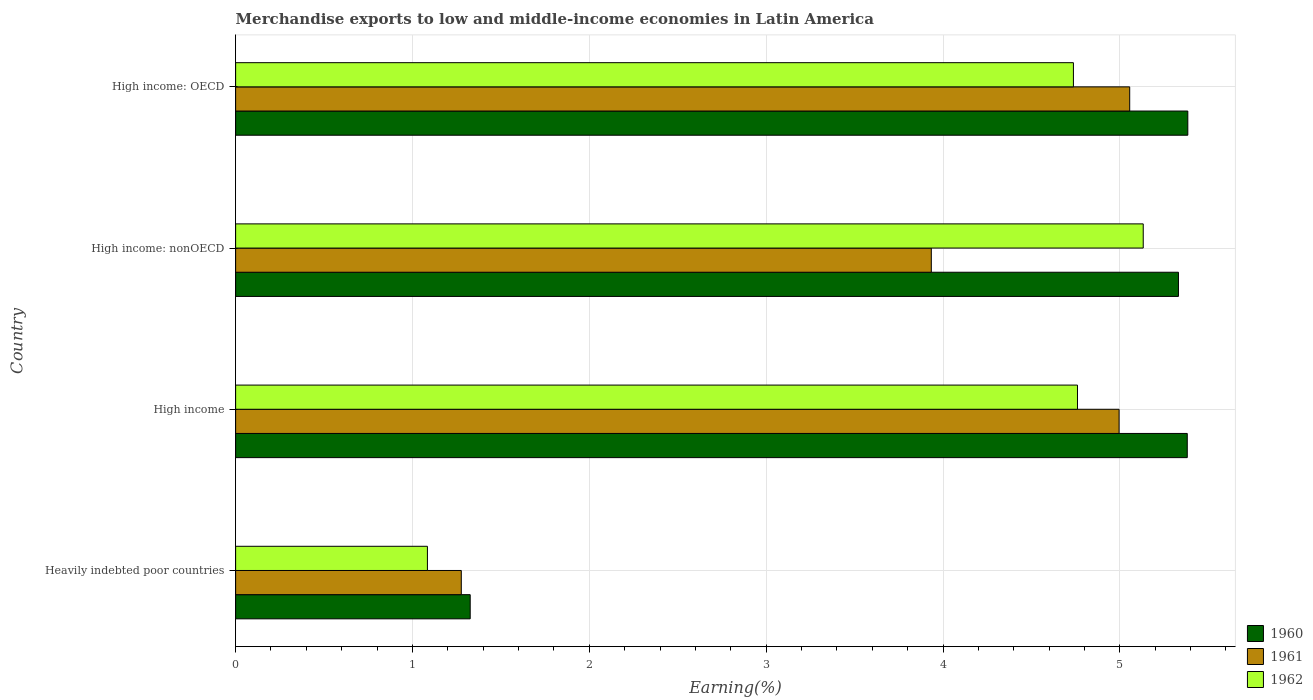How many bars are there on the 1st tick from the top?
Make the answer very short. 3. What is the label of the 2nd group of bars from the top?
Your response must be concise. High income: nonOECD. What is the percentage of amount earned from merchandise exports in 1961 in High income: OECD?
Make the answer very short. 5.06. Across all countries, what is the maximum percentage of amount earned from merchandise exports in 1960?
Keep it short and to the point. 5.38. Across all countries, what is the minimum percentage of amount earned from merchandise exports in 1960?
Offer a very short reply. 1.33. In which country was the percentage of amount earned from merchandise exports in 1962 maximum?
Keep it short and to the point. High income: nonOECD. In which country was the percentage of amount earned from merchandise exports in 1962 minimum?
Offer a very short reply. Heavily indebted poor countries. What is the total percentage of amount earned from merchandise exports in 1961 in the graph?
Keep it short and to the point. 15.26. What is the difference between the percentage of amount earned from merchandise exports in 1961 in Heavily indebted poor countries and that in High income: nonOECD?
Give a very brief answer. -2.66. What is the difference between the percentage of amount earned from merchandise exports in 1962 in High income: OECD and the percentage of amount earned from merchandise exports in 1961 in High income?
Give a very brief answer. -0.26. What is the average percentage of amount earned from merchandise exports in 1961 per country?
Provide a short and direct response. 3.82. What is the difference between the percentage of amount earned from merchandise exports in 1960 and percentage of amount earned from merchandise exports in 1961 in High income?
Keep it short and to the point. 0.39. In how many countries, is the percentage of amount earned from merchandise exports in 1961 greater than 2.2 %?
Your answer should be compact. 3. What is the ratio of the percentage of amount earned from merchandise exports in 1962 in High income to that in High income: OECD?
Keep it short and to the point. 1. Is the difference between the percentage of amount earned from merchandise exports in 1960 in Heavily indebted poor countries and High income: nonOECD greater than the difference between the percentage of amount earned from merchandise exports in 1961 in Heavily indebted poor countries and High income: nonOECD?
Your response must be concise. No. What is the difference between the highest and the second highest percentage of amount earned from merchandise exports in 1960?
Your answer should be very brief. 0. What is the difference between the highest and the lowest percentage of amount earned from merchandise exports in 1961?
Offer a terse response. 3.78. In how many countries, is the percentage of amount earned from merchandise exports in 1960 greater than the average percentage of amount earned from merchandise exports in 1960 taken over all countries?
Provide a short and direct response. 3. What does the 2nd bar from the bottom in High income represents?
Your response must be concise. 1961. Is it the case that in every country, the sum of the percentage of amount earned from merchandise exports in 1962 and percentage of amount earned from merchandise exports in 1961 is greater than the percentage of amount earned from merchandise exports in 1960?
Keep it short and to the point. Yes. How many countries are there in the graph?
Offer a very short reply. 4. Does the graph contain any zero values?
Offer a terse response. No. Does the graph contain grids?
Give a very brief answer. Yes. How are the legend labels stacked?
Offer a terse response. Vertical. What is the title of the graph?
Make the answer very short. Merchandise exports to low and middle-income economies in Latin America. What is the label or title of the X-axis?
Offer a very short reply. Earning(%). What is the Earning(%) in 1960 in Heavily indebted poor countries?
Offer a very short reply. 1.33. What is the Earning(%) in 1961 in Heavily indebted poor countries?
Your answer should be compact. 1.28. What is the Earning(%) of 1962 in Heavily indebted poor countries?
Provide a short and direct response. 1.08. What is the Earning(%) of 1960 in High income?
Make the answer very short. 5.38. What is the Earning(%) of 1961 in High income?
Provide a succinct answer. 5. What is the Earning(%) of 1962 in High income?
Your response must be concise. 4.76. What is the Earning(%) of 1960 in High income: nonOECD?
Keep it short and to the point. 5.33. What is the Earning(%) of 1961 in High income: nonOECD?
Make the answer very short. 3.93. What is the Earning(%) in 1962 in High income: nonOECD?
Your response must be concise. 5.13. What is the Earning(%) of 1960 in High income: OECD?
Give a very brief answer. 5.38. What is the Earning(%) of 1961 in High income: OECD?
Give a very brief answer. 5.06. What is the Earning(%) of 1962 in High income: OECD?
Give a very brief answer. 4.74. Across all countries, what is the maximum Earning(%) in 1960?
Offer a terse response. 5.38. Across all countries, what is the maximum Earning(%) of 1961?
Make the answer very short. 5.06. Across all countries, what is the maximum Earning(%) in 1962?
Provide a succinct answer. 5.13. Across all countries, what is the minimum Earning(%) in 1960?
Provide a succinct answer. 1.33. Across all countries, what is the minimum Earning(%) in 1961?
Give a very brief answer. 1.28. Across all countries, what is the minimum Earning(%) of 1962?
Ensure brevity in your answer.  1.08. What is the total Earning(%) of 1960 in the graph?
Your response must be concise. 17.42. What is the total Earning(%) in 1961 in the graph?
Provide a short and direct response. 15.26. What is the total Earning(%) in 1962 in the graph?
Make the answer very short. 15.71. What is the difference between the Earning(%) in 1960 in Heavily indebted poor countries and that in High income?
Make the answer very short. -4.05. What is the difference between the Earning(%) in 1961 in Heavily indebted poor countries and that in High income?
Offer a very short reply. -3.72. What is the difference between the Earning(%) in 1962 in Heavily indebted poor countries and that in High income?
Your answer should be compact. -3.68. What is the difference between the Earning(%) of 1960 in Heavily indebted poor countries and that in High income: nonOECD?
Make the answer very short. -4. What is the difference between the Earning(%) of 1961 in Heavily indebted poor countries and that in High income: nonOECD?
Ensure brevity in your answer.  -2.66. What is the difference between the Earning(%) in 1962 in Heavily indebted poor countries and that in High income: nonOECD?
Provide a succinct answer. -4.05. What is the difference between the Earning(%) of 1960 in Heavily indebted poor countries and that in High income: OECD?
Your answer should be compact. -4.06. What is the difference between the Earning(%) of 1961 in Heavily indebted poor countries and that in High income: OECD?
Provide a succinct answer. -3.78. What is the difference between the Earning(%) of 1962 in Heavily indebted poor countries and that in High income: OECD?
Keep it short and to the point. -3.65. What is the difference between the Earning(%) of 1960 in High income and that in High income: nonOECD?
Your response must be concise. 0.05. What is the difference between the Earning(%) in 1961 in High income and that in High income: nonOECD?
Offer a very short reply. 1.06. What is the difference between the Earning(%) in 1962 in High income and that in High income: nonOECD?
Offer a very short reply. -0.37. What is the difference between the Earning(%) of 1960 in High income and that in High income: OECD?
Give a very brief answer. -0. What is the difference between the Earning(%) of 1961 in High income and that in High income: OECD?
Offer a terse response. -0.06. What is the difference between the Earning(%) of 1962 in High income and that in High income: OECD?
Provide a short and direct response. 0.02. What is the difference between the Earning(%) in 1960 in High income: nonOECD and that in High income: OECD?
Provide a short and direct response. -0.05. What is the difference between the Earning(%) of 1961 in High income: nonOECD and that in High income: OECD?
Make the answer very short. -1.12. What is the difference between the Earning(%) of 1962 in High income: nonOECD and that in High income: OECD?
Provide a short and direct response. 0.39. What is the difference between the Earning(%) in 1960 in Heavily indebted poor countries and the Earning(%) in 1961 in High income?
Ensure brevity in your answer.  -3.67. What is the difference between the Earning(%) of 1960 in Heavily indebted poor countries and the Earning(%) of 1962 in High income?
Give a very brief answer. -3.43. What is the difference between the Earning(%) of 1961 in Heavily indebted poor countries and the Earning(%) of 1962 in High income?
Provide a succinct answer. -3.48. What is the difference between the Earning(%) in 1960 in Heavily indebted poor countries and the Earning(%) in 1961 in High income: nonOECD?
Provide a short and direct response. -2.61. What is the difference between the Earning(%) in 1960 in Heavily indebted poor countries and the Earning(%) in 1962 in High income: nonOECD?
Provide a succinct answer. -3.81. What is the difference between the Earning(%) of 1961 in Heavily indebted poor countries and the Earning(%) of 1962 in High income: nonOECD?
Provide a succinct answer. -3.86. What is the difference between the Earning(%) in 1960 in Heavily indebted poor countries and the Earning(%) in 1961 in High income: OECD?
Your answer should be very brief. -3.73. What is the difference between the Earning(%) in 1960 in Heavily indebted poor countries and the Earning(%) in 1962 in High income: OECD?
Keep it short and to the point. -3.41. What is the difference between the Earning(%) in 1961 in Heavily indebted poor countries and the Earning(%) in 1962 in High income: OECD?
Provide a short and direct response. -3.46. What is the difference between the Earning(%) of 1960 in High income and the Earning(%) of 1961 in High income: nonOECD?
Make the answer very short. 1.45. What is the difference between the Earning(%) in 1960 in High income and the Earning(%) in 1962 in High income: nonOECD?
Make the answer very short. 0.25. What is the difference between the Earning(%) in 1961 in High income and the Earning(%) in 1962 in High income: nonOECD?
Keep it short and to the point. -0.14. What is the difference between the Earning(%) of 1960 in High income and the Earning(%) of 1961 in High income: OECD?
Offer a terse response. 0.33. What is the difference between the Earning(%) of 1960 in High income and the Earning(%) of 1962 in High income: OECD?
Your answer should be compact. 0.64. What is the difference between the Earning(%) of 1961 in High income and the Earning(%) of 1962 in High income: OECD?
Provide a succinct answer. 0.26. What is the difference between the Earning(%) in 1960 in High income: nonOECD and the Earning(%) in 1961 in High income: OECD?
Make the answer very short. 0.28. What is the difference between the Earning(%) of 1960 in High income: nonOECD and the Earning(%) of 1962 in High income: OECD?
Your answer should be compact. 0.59. What is the difference between the Earning(%) of 1961 in High income: nonOECD and the Earning(%) of 1962 in High income: OECD?
Offer a very short reply. -0.8. What is the average Earning(%) of 1960 per country?
Provide a short and direct response. 4.36. What is the average Earning(%) of 1961 per country?
Your answer should be very brief. 3.82. What is the average Earning(%) of 1962 per country?
Your answer should be very brief. 3.93. What is the difference between the Earning(%) of 1960 and Earning(%) of 1961 in Heavily indebted poor countries?
Offer a very short reply. 0.05. What is the difference between the Earning(%) in 1960 and Earning(%) in 1962 in Heavily indebted poor countries?
Give a very brief answer. 0.24. What is the difference between the Earning(%) in 1961 and Earning(%) in 1962 in Heavily indebted poor countries?
Your answer should be compact. 0.19. What is the difference between the Earning(%) of 1960 and Earning(%) of 1961 in High income?
Your answer should be very brief. 0.39. What is the difference between the Earning(%) in 1960 and Earning(%) in 1962 in High income?
Offer a terse response. 0.62. What is the difference between the Earning(%) of 1961 and Earning(%) of 1962 in High income?
Offer a terse response. 0.24. What is the difference between the Earning(%) of 1960 and Earning(%) of 1961 in High income: nonOECD?
Provide a short and direct response. 1.4. What is the difference between the Earning(%) of 1960 and Earning(%) of 1962 in High income: nonOECD?
Your response must be concise. 0.2. What is the difference between the Earning(%) in 1961 and Earning(%) in 1962 in High income: nonOECD?
Offer a very short reply. -1.2. What is the difference between the Earning(%) in 1960 and Earning(%) in 1961 in High income: OECD?
Provide a short and direct response. 0.33. What is the difference between the Earning(%) of 1960 and Earning(%) of 1962 in High income: OECD?
Provide a short and direct response. 0.65. What is the difference between the Earning(%) of 1961 and Earning(%) of 1962 in High income: OECD?
Your answer should be compact. 0.32. What is the ratio of the Earning(%) of 1960 in Heavily indebted poor countries to that in High income?
Offer a terse response. 0.25. What is the ratio of the Earning(%) in 1961 in Heavily indebted poor countries to that in High income?
Offer a very short reply. 0.26. What is the ratio of the Earning(%) in 1962 in Heavily indebted poor countries to that in High income?
Your answer should be compact. 0.23. What is the ratio of the Earning(%) in 1960 in Heavily indebted poor countries to that in High income: nonOECD?
Provide a short and direct response. 0.25. What is the ratio of the Earning(%) of 1961 in Heavily indebted poor countries to that in High income: nonOECD?
Provide a short and direct response. 0.32. What is the ratio of the Earning(%) of 1962 in Heavily indebted poor countries to that in High income: nonOECD?
Your answer should be compact. 0.21. What is the ratio of the Earning(%) of 1960 in Heavily indebted poor countries to that in High income: OECD?
Your answer should be very brief. 0.25. What is the ratio of the Earning(%) in 1961 in Heavily indebted poor countries to that in High income: OECD?
Provide a short and direct response. 0.25. What is the ratio of the Earning(%) of 1962 in Heavily indebted poor countries to that in High income: OECD?
Your answer should be compact. 0.23. What is the ratio of the Earning(%) in 1960 in High income to that in High income: nonOECD?
Your answer should be compact. 1.01. What is the ratio of the Earning(%) in 1961 in High income to that in High income: nonOECD?
Your response must be concise. 1.27. What is the ratio of the Earning(%) of 1962 in High income to that in High income: nonOECD?
Your answer should be very brief. 0.93. What is the ratio of the Earning(%) of 1961 in High income to that in High income: OECD?
Keep it short and to the point. 0.99. What is the ratio of the Earning(%) in 1962 in High income to that in High income: OECD?
Keep it short and to the point. 1. What is the ratio of the Earning(%) in 1960 in High income: nonOECD to that in High income: OECD?
Give a very brief answer. 0.99. What is the ratio of the Earning(%) in 1961 in High income: nonOECD to that in High income: OECD?
Ensure brevity in your answer.  0.78. What is the difference between the highest and the second highest Earning(%) in 1960?
Offer a terse response. 0. What is the difference between the highest and the second highest Earning(%) in 1962?
Your answer should be compact. 0.37. What is the difference between the highest and the lowest Earning(%) in 1960?
Provide a short and direct response. 4.06. What is the difference between the highest and the lowest Earning(%) in 1961?
Offer a very short reply. 3.78. What is the difference between the highest and the lowest Earning(%) in 1962?
Give a very brief answer. 4.05. 